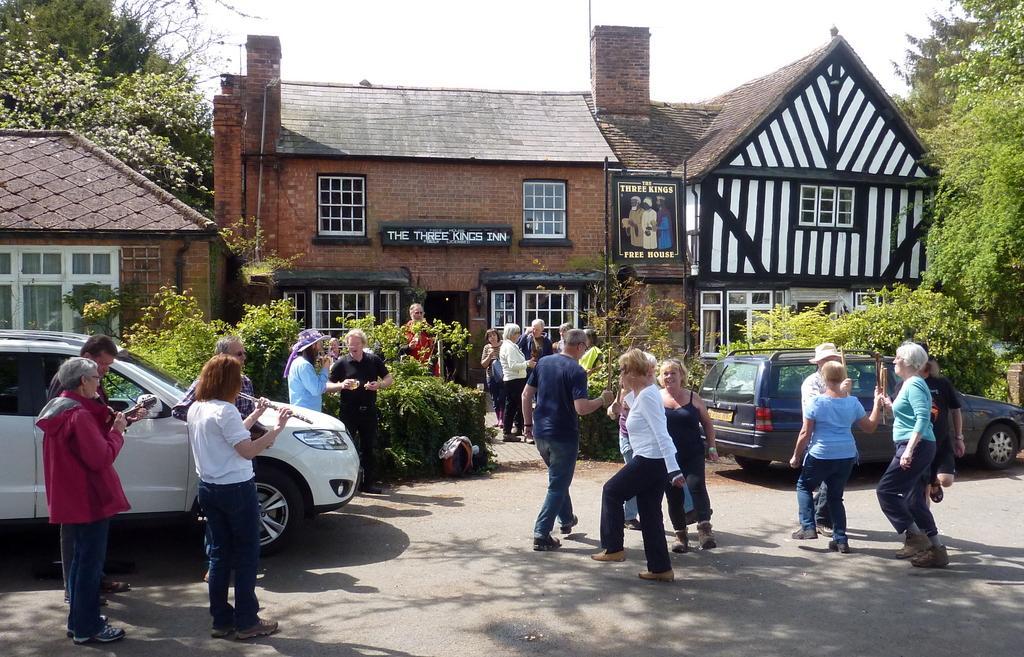Please provide a concise description of this image. In this picture I can see buildings, trees and few people are standing and few are walking and I can see couple of cars and plants and I can see a woman playing flute and I can see a board with some text and I can see text on the wall and I can see a cloudy sky. 